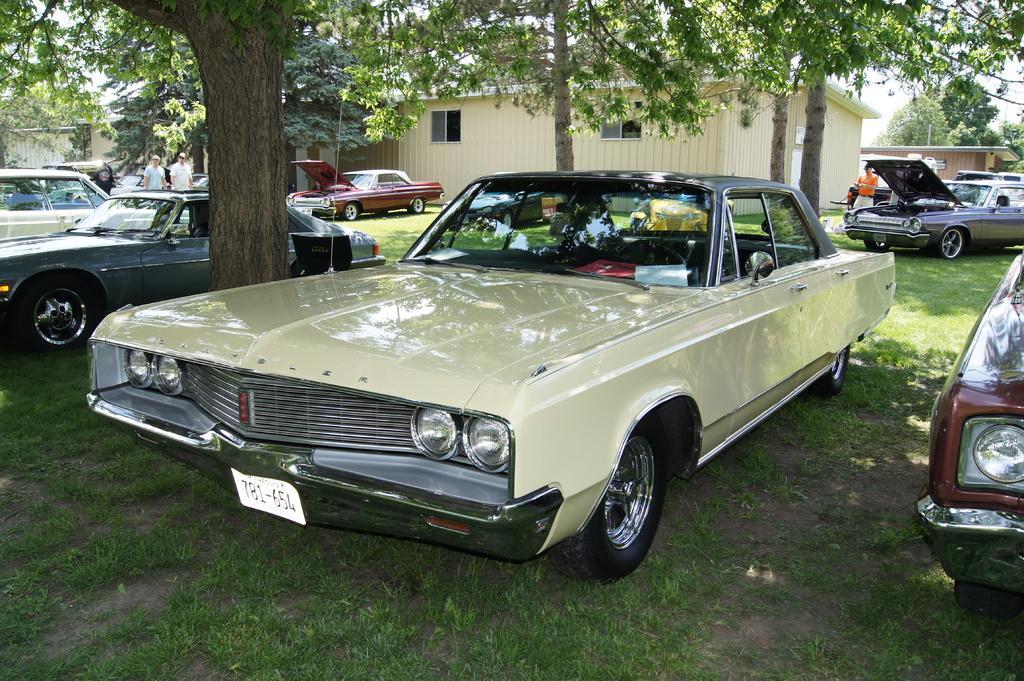How would you summarize this image in a sentence or two? In this image in the center there are a group of cars, and there are some people. At the bottom there is grass, and in the background there are houses and trees. 